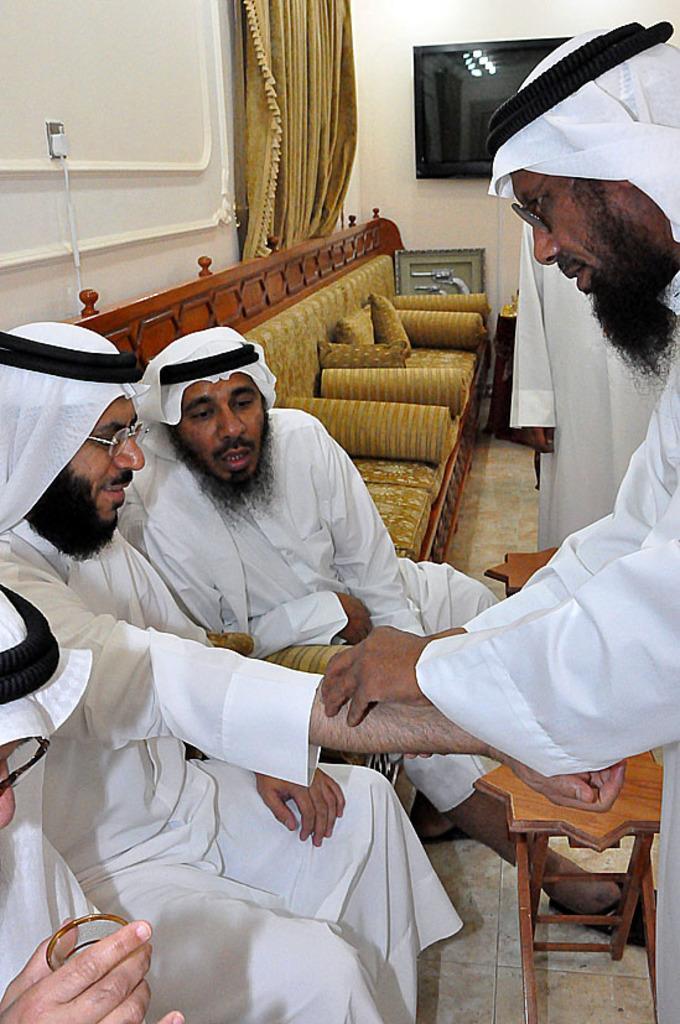Describe this image in one or two sentences. In a picture there are four people where there are sitting on the sofa at the right corner two persons are standing and in front of them there are small tables and at the left corner there is another person is and holding a glass and left corner of the picture there is one tv attached to a wall and a curtain. 